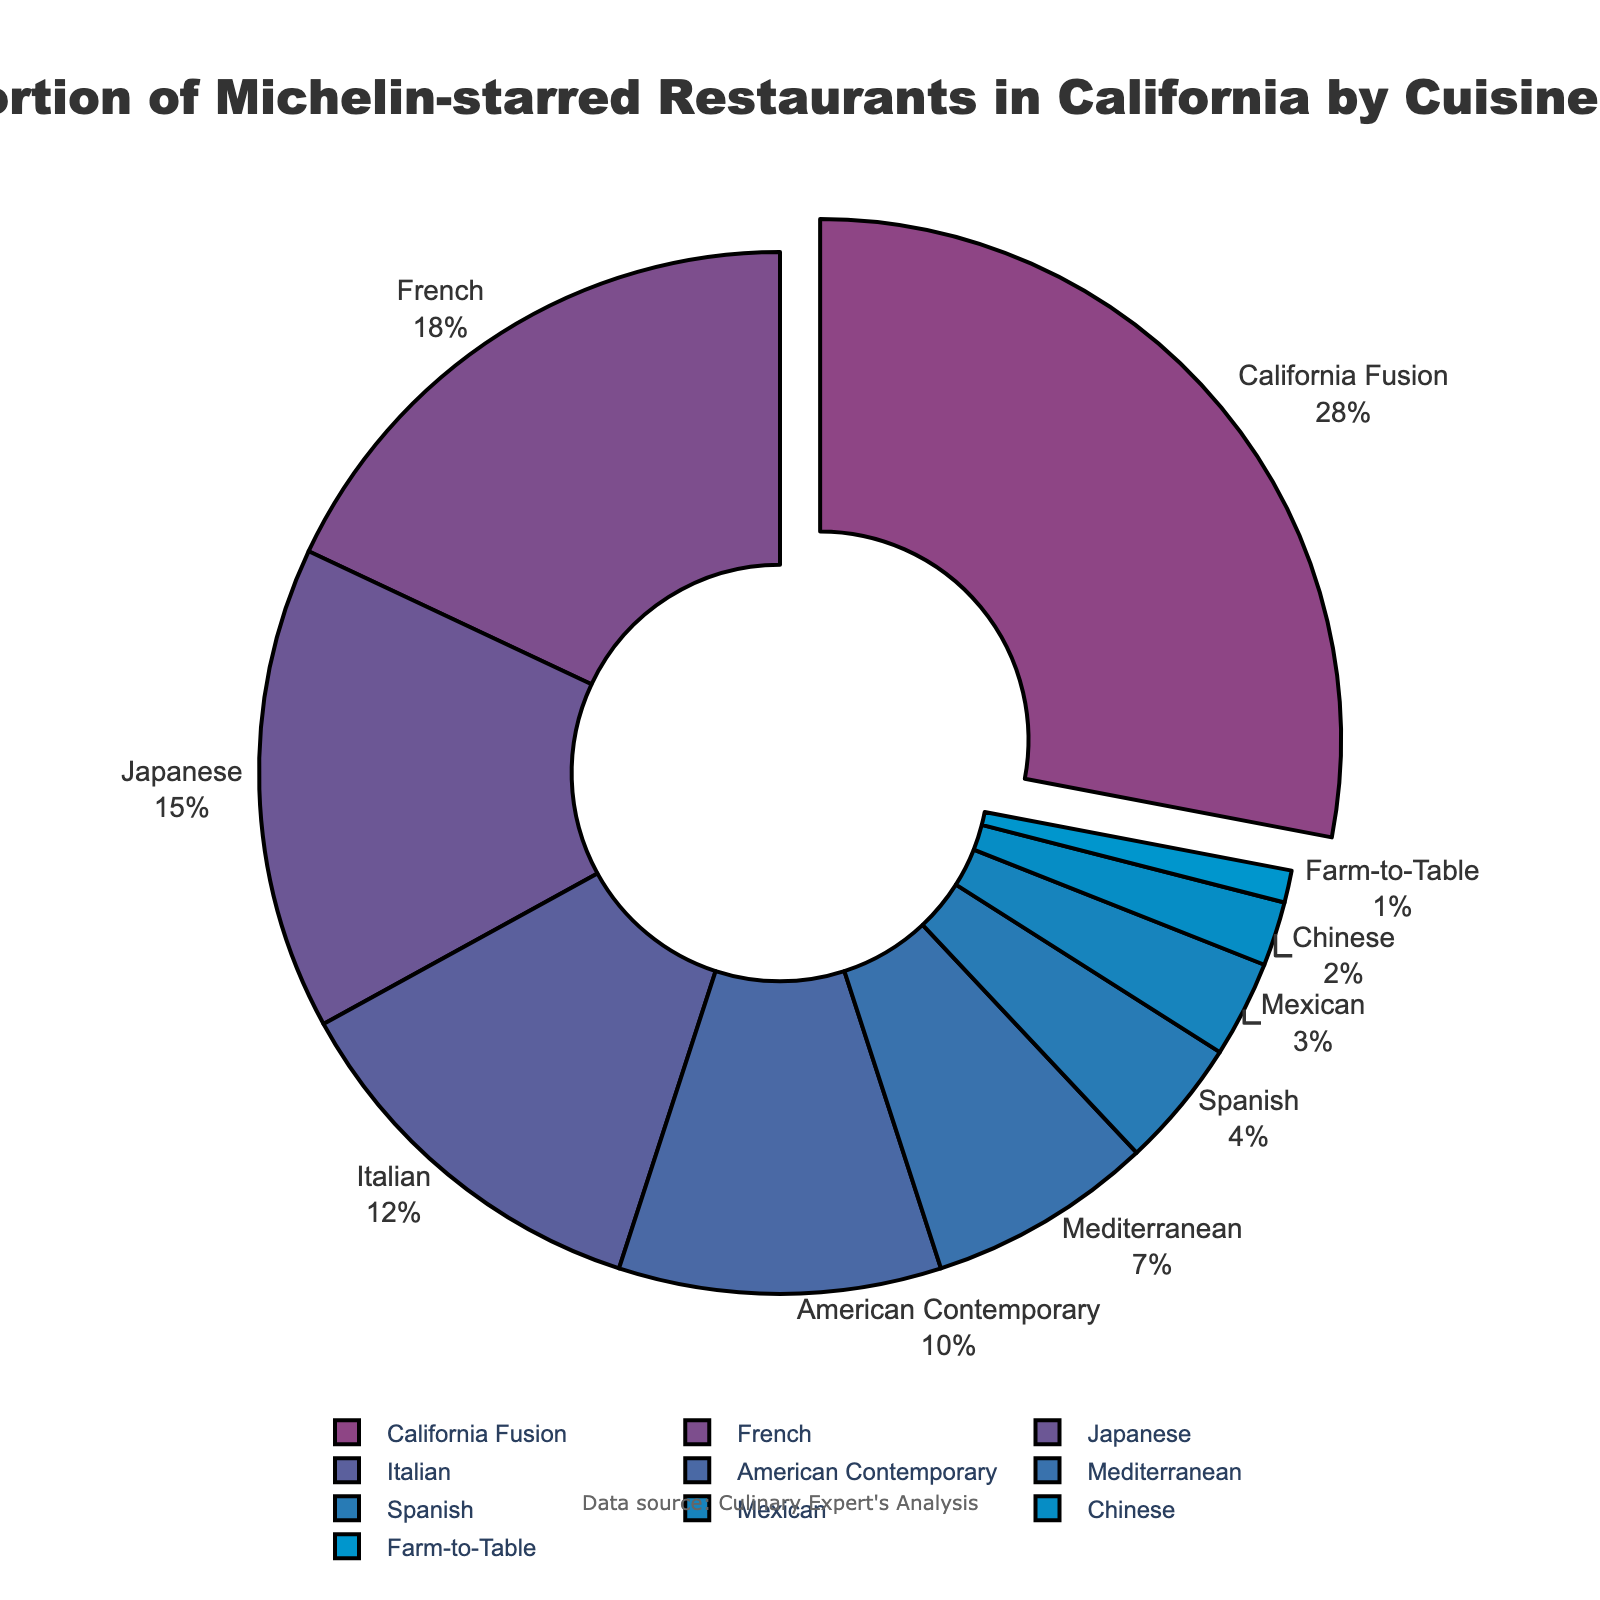What percentage of Michelin-starred restaurants in California feature Italian cuisine? The Italian cuisine wedge on the pie chart is 12%, thus 12% of Michelin-starred restaurants in California feature Italian cuisine.
Answer: 12% How do the proportions of French and Japanese cuisines compare? French cuisine makes up 18% and Japanese cuisine makes up 15% of the Michelin-starred restaurants in California. Comparing the two, French cuisine has a 3% higher proportion than Japanese cuisine.
Answer: French is 3% more Which cuisine type has the smallest proportion of Michelin-starred restaurants? The Farm-to-Table cuisine type has the smallest proportion at 1%, as seen on the pie chart.
Answer: Farm-to-Table What's the combined percentage of Michelin-starred restaurants for American Contemporary and Mediterranean cuisines? The chart indicates American Contemporary at 10% and Mediterranean at 7%. Adding these percentages gives 10% + 7% = 17%.
Answer: 17% Which cuisine is represented by the largest wedge? The largest wedge in the pie chart corresponds to the California Fusion cuisine, which comprises 28% of the Michelin-starred restaurants in California.
Answer: California Fusion How does the proportion of Mexican cuisine compare to Chinese cuisine in Michelin-starred restaurants? Mexican cuisine has a proportion of 3% and Chinese cuisine has a proportion of 2%. Therefore, Mexican cuisine has a 1% higher proportion than Chinese cuisine.
Answer: Mexican is 1% more What's the total percentage of Michelin-starred restaurants that feature French, Japanese, and Italian cuisines? The proportions are: French - 18%, Japanese - 15%, and Italian - 12%. Summing these gives 18% + 15% + 12% = 45%.
Answer: 45% Which cuisine has a lower representation: Mediterranean or Spanish? The Mediterranean cuisine has a proportion of 7%, while the Spanish cuisine has a proportion of 4%. Therefore, Spanish has a lower representation.
Answer: Spanish What's the difference in the proportion of Michelin-starred restaurants between California Fusion and American Contemporary cuisines? California Fusion has 28% and American Contemporary has 10%. Subtracting gives 28% - 10% = 18%.
Answer: 18% What percentage of Michelin-starred restaurants feature cuisines other than the top three? The top three cuisines are California Fusion (28%), French (18%), and Japanese (15%). Summing these gives 28% + 18% + 15% = 61%. Subtracting from 100% gives 100% - 61% = 39%.
Answer: 39% 